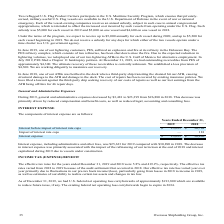According to Overseas Shipholding Group's financial document, How much was Interest expense, including administrative and other fees for 2019? According to the financial document, $25,633. The relevant text states: "ense, including administrative and other fees, was $25,633 for 2019 compared with $30,890 in 2018. The decrease in interest expense was primarily associated wi..." Also, How much was Interest expense, including administrative and other fees for 2018? According to the financial document, $30,890. The relevant text states: "and other fees, was $25,633 for 2019 compared with $30,890 in 2018. The decrease in interest expense was primarily associated with the impact of the refinancin..." Also, What led to the decrease in interest expense? primarily associated with the impact of the refinancing of our term loan at the end of 2018 and interest capitalized during 2019 due to vessels under construction.. The document states: ",890 in 2018. The decrease in interest expense was primarily associated with the impact of the refinancing of our term loan at the end of 2018 and int..." Also, can you calculate: What is the change in Interest before impact of interest rate caps from Years Ended December 31, 2018 to 2019? Based on the calculation: 25,633-30,709, the result is -5076. This is based on the information: "st before impact of interest rate caps $ 25,633 $ 30,709 Interest before impact of interest rate caps $ 25,633 $ 30,709..." The key data points involved are: 25,633, 30,709. Also, can you calculate: What is the change in Interest expense from Years Ended December 31, 2018 to 2019? Based on the calculation: 25,633-30,890, the result is -5257. This is based on the information: "Interest expense $ 25,633 $ 30,890 Interest before impact of interest rate caps $ 25,633 $ 30,709..." The key data points involved are: 25,633, 30,890. Also, can you calculate: What is the average Interest before impact of interest rate caps for Years Ended December 31, 2018 to 2019? To answer this question, I need to perform calculations using the financial data. The calculation is: (25,633+30,709) / 2, which equals 28171. This is based on the information: "st before impact of interest rate caps $ 25,633 $ 30,709 Interest before impact of interest rate caps $ 25,633 $ 30,709..." The key data points involved are: 25,633, 30,709. 